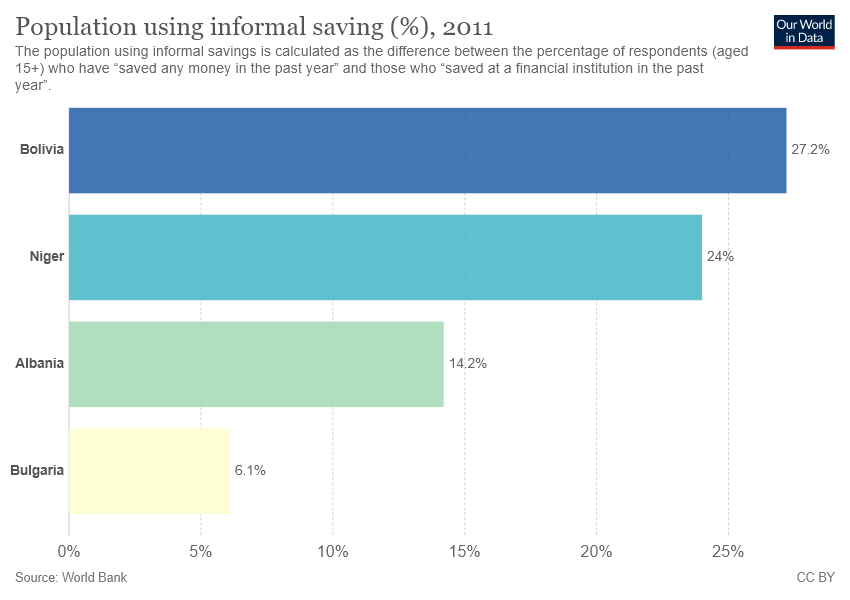Draw attention to some important aspects in this diagram. The average value of Bulgaria and Bolivia is 16.65. Bulgaria is represented by the yellow color in the country bar. 